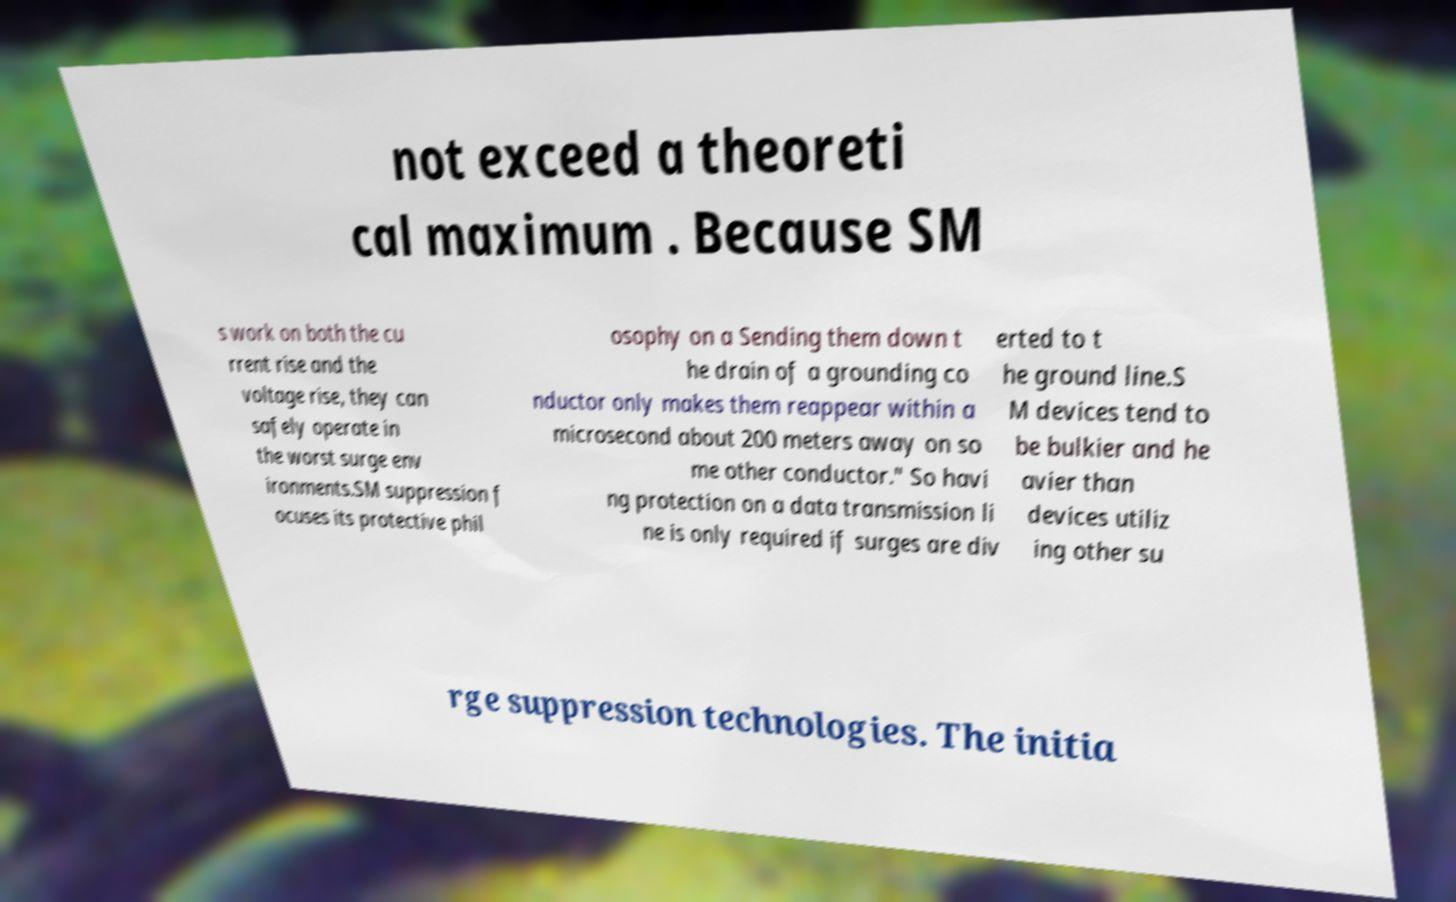Can you accurately transcribe the text from the provided image for me? not exceed a theoreti cal maximum . Because SM s work on both the cu rrent rise and the voltage rise, they can safely operate in the worst surge env ironments.SM suppression f ocuses its protective phil osophy on a Sending them down t he drain of a grounding co nductor only makes them reappear within a microsecond about 200 meters away on so me other conductor." So havi ng protection on a data transmission li ne is only required if surges are div erted to t he ground line.S M devices tend to be bulkier and he avier than devices utiliz ing other su rge suppression technologies. The initia 